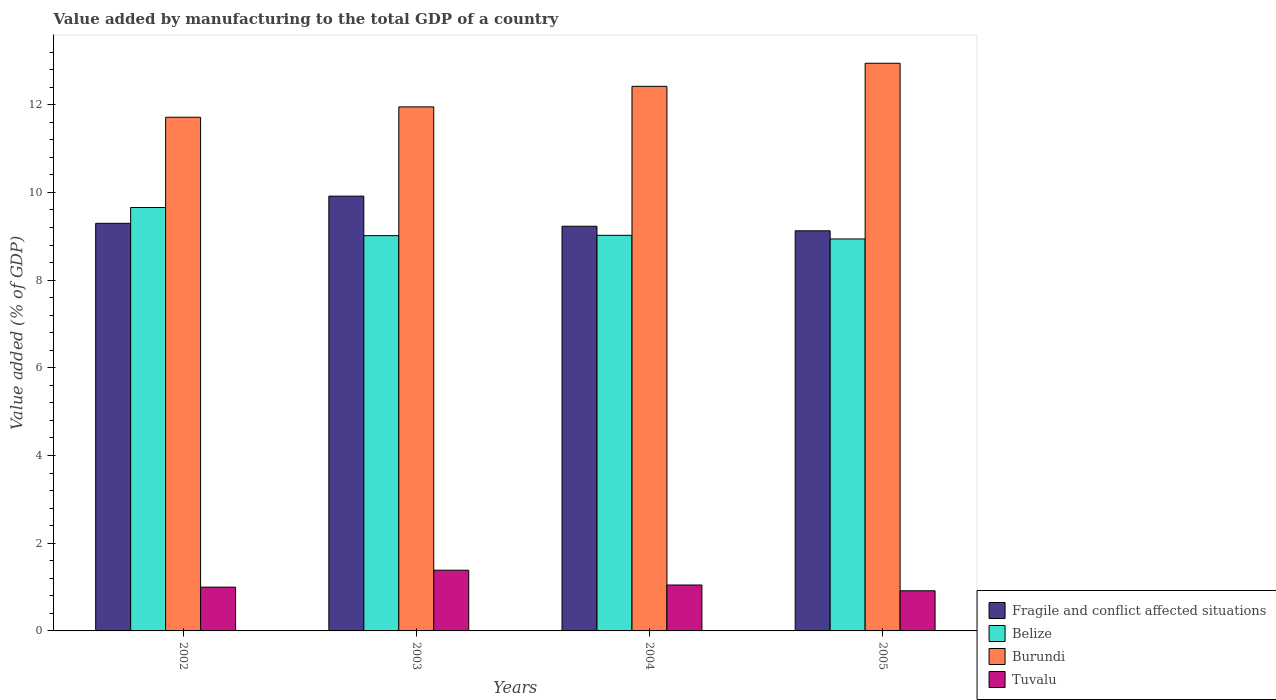How many different coloured bars are there?
Your answer should be very brief. 4. How many groups of bars are there?
Keep it short and to the point. 4. How many bars are there on the 3rd tick from the left?
Offer a terse response. 4. What is the value added by manufacturing to the total GDP in Burundi in 2003?
Ensure brevity in your answer.  11.95. Across all years, what is the maximum value added by manufacturing to the total GDP in Tuvalu?
Give a very brief answer. 1.38. Across all years, what is the minimum value added by manufacturing to the total GDP in Fragile and conflict affected situations?
Ensure brevity in your answer.  9.12. In which year was the value added by manufacturing to the total GDP in Tuvalu maximum?
Make the answer very short. 2003. What is the total value added by manufacturing to the total GDP in Burundi in the graph?
Your answer should be compact. 49.03. What is the difference between the value added by manufacturing to the total GDP in Belize in 2003 and that in 2004?
Keep it short and to the point. -0.01. What is the difference between the value added by manufacturing to the total GDP in Belize in 2005 and the value added by manufacturing to the total GDP in Fragile and conflict affected situations in 2002?
Provide a succinct answer. -0.36. What is the average value added by manufacturing to the total GDP in Fragile and conflict affected situations per year?
Offer a terse response. 9.39. In the year 2003, what is the difference between the value added by manufacturing to the total GDP in Burundi and value added by manufacturing to the total GDP in Belize?
Offer a terse response. 2.94. What is the ratio of the value added by manufacturing to the total GDP in Fragile and conflict affected situations in 2002 to that in 2005?
Your answer should be compact. 1.02. What is the difference between the highest and the second highest value added by manufacturing to the total GDP in Burundi?
Ensure brevity in your answer.  0.53. What is the difference between the highest and the lowest value added by manufacturing to the total GDP in Burundi?
Give a very brief answer. 1.23. In how many years, is the value added by manufacturing to the total GDP in Belize greater than the average value added by manufacturing to the total GDP in Belize taken over all years?
Give a very brief answer. 1. Is it the case that in every year, the sum of the value added by manufacturing to the total GDP in Tuvalu and value added by manufacturing to the total GDP in Burundi is greater than the sum of value added by manufacturing to the total GDP in Fragile and conflict affected situations and value added by manufacturing to the total GDP in Belize?
Provide a succinct answer. No. What does the 4th bar from the left in 2005 represents?
Your answer should be very brief. Tuvalu. What does the 2nd bar from the right in 2005 represents?
Make the answer very short. Burundi. How many bars are there?
Your answer should be compact. 16. Are all the bars in the graph horizontal?
Keep it short and to the point. No. How many years are there in the graph?
Your response must be concise. 4. Does the graph contain any zero values?
Provide a short and direct response. No. Does the graph contain grids?
Keep it short and to the point. No. How many legend labels are there?
Offer a terse response. 4. How are the legend labels stacked?
Offer a terse response. Vertical. What is the title of the graph?
Offer a very short reply. Value added by manufacturing to the total GDP of a country. Does "Malaysia" appear as one of the legend labels in the graph?
Your response must be concise. No. What is the label or title of the X-axis?
Provide a short and direct response. Years. What is the label or title of the Y-axis?
Your response must be concise. Value added (% of GDP). What is the Value added (% of GDP) in Fragile and conflict affected situations in 2002?
Keep it short and to the point. 9.3. What is the Value added (% of GDP) of Belize in 2002?
Keep it short and to the point. 9.66. What is the Value added (% of GDP) of Burundi in 2002?
Your response must be concise. 11.71. What is the Value added (% of GDP) in Tuvalu in 2002?
Offer a terse response. 1. What is the Value added (% of GDP) of Fragile and conflict affected situations in 2003?
Your answer should be very brief. 9.92. What is the Value added (% of GDP) in Belize in 2003?
Make the answer very short. 9.01. What is the Value added (% of GDP) of Burundi in 2003?
Your response must be concise. 11.95. What is the Value added (% of GDP) in Tuvalu in 2003?
Offer a very short reply. 1.38. What is the Value added (% of GDP) of Fragile and conflict affected situations in 2004?
Give a very brief answer. 9.23. What is the Value added (% of GDP) in Belize in 2004?
Make the answer very short. 9.02. What is the Value added (% of GDP) in Burundi in 2004?
Keep it short and to the point. 12.42. What is the Value added (% of GDP) in Tuvalu in 2004?
Provide a short and direct response. 1.05. What is the Value added (% of GDP) in Fragile and conflict affected situations in 2005?
Ensure brevity in your answer.  9.12. What is the Value added (% of GDP) in Belize in 2005?
Keep it short and to the point. 8.94. What is the Value added (% of GDP) of Burundi in 2005?
Provide a short and direct response. 12.95. What is the Value added (% of GDP) in Tuvalu in 2005?
Your answer should be compact. 0.92. Across all years, what is the maximum Value added (% of GDP) of Fragile and conflict affected situations?
Offer a very short reply. 9.92. Across all years, what is the maximum Value added (% of GDP) of Belize?
Keep it short and to the point. 9.66. Across all years, what is the maximum Value added (% of GDP) of Burundi?
Provide a succinct answer. 12.95. Across all years, what is the maximum Value added (% of GDP) of Tuvalu?
Give a very brief answer. 1.38. Across all years, what is the minimum Value added (% of GDP) of Fragile and conflict affected situations?
Your answer should be compact. 9.12. Across all years, what is the minimum Value added (% of GDP) in Belize?
Offer a very short reply. 8.94. Across all years, what is the minimum Value added (% of GDP) of Burundi?
Offer a terse response. 11.71. Across all years, what is the minimum Value added (% of GDP) in Tuvalu?
Make the answer very short. 0.92. What is the total Value added (% of GDP) in Fragile and conflict affected situations in the graph?
Keep it short and to the point. 37.56. What is the total Value added (% of GDP) of Belize in the graph?
Keep it short and to the point. 36.63. What is the total Value added (% of GDP) in Burundi in the graph?
Ensure brevity in your answer.  49.03. What is the total Value added (% of GDP) of Tuvalu in the graph?
Ensure brevity in your answer.  4.35. What is the difference between the Value added (% of GDP) in Fragile and conflict affected situations in 2002 and that in 2003?
Your answer should be very brief. -0.62. What is the difference between the Value added (% of GDP) of Belize in 2002 and that in 2003?
Your answer should be compact. 0.64. What is the difference between the Value added (% of GDP) of Burundi in 2002 and that in 2003?
Offer a terse response. -0.24. What is the difference between the Value added (% of GDP) of Tuvalu in 2002 and that in 2003?
Ensure brevity in your answer.  -0.39. What is the difference between the Value added (% of GDP) of Fragile and conflict affected situations in 2002 and that in 2004?
Offer a terse response. 0.07. What is the difference between the Value added (% of GDP) in Belize in 2002 and that in 2004?
Provide a short and direct response. 0.63. What is the difference between the Value added (% of GDP) in Burundi in 2002 and that in 2004?
Offer a terse response. -0.7. What is the difference between the Value added (% of GDP) in Tuvalu in 2002 and that in 2004?
Your answer should be compact. -0.05. What is the difference between the Value added (% of GDP) of Fragile and conflict affected situations in 2002 and that in 2005?
Keep it short and to the point. 0.17. What is the difference between the Value added (% of GDP) of Belize in 2002 and that in 2005?
Provide a succinct answer. 0.72. What is the difference between the Value added (% of GDP) of Burundi in 2002 and that in 2005?
Provide a succinct answer. -1.23. What is the difference between the Value added (% of GDP) in Tuvalu in 2002 and that in 2005?
Give a very brief answer. 0.08. What is the difference between the Value added (% of GDP) of Fragile and conflict affected situations in 2003 and that in 2004?
Your answer should be compact. 0.69. What is the difference between the Value added (% of GDP) in Belize in 2003 and that in 2004?
Keep it short and to the point. -0.01. What is the difference between the Value added (% of GDP) in Burundi in 2003 and that in 2004?
Your answer should be compact. -0.47. What is the difference between the Value added (% of GDP) of Tuvalu in 2003 and that in 2004?
Your response must be concise. 0.34. What is the difference between the Value added (% of GDP) of Fragile and conflict affected situations in 2003 and that in 2005?
Your response must be concise. 0.79. What is the difference between the Value added (% of GDP) of Belize in 2003 and that in 2005?
Offer a very short reply. 0.08. What is the difference between the Value added (% of GDP) in Burundi in 2003 and that in 2005?
Make the answer very short. -0.99. What is the difference between the Value added (% of GDP) of Tuvalu in 2003 and that in 2005?
Your response must be concise. 0.47. What is the difference between the Value added (% of GDP) of Fragile and conflict affected situations in 2004 and that in 2005?
Make the answer very short. 0.1. What is the difference between the Value added (% of GDP) in Belize in 2004 and that in 2005?
Offer a very short reply. 0.08. What is the difference between the Value added (% of GDP) of Burundi in 2004 and that in 2005?
Your answer should be compact. -0.53. What is the difference between the Value added (% of GDP) in Tuvalu in 2004 and that in 2005?
Provide a short and direct response. 0.13. What is the difference between the Value added (% of GDP) in Fragile and conflict affected situations in 2002 and the Value added (% of GDP) in Belize in 2003?
Keep it short and to the point. 0.28. What is the difference between the Value added (% of GDP) of Fragile and conflict affected situations in 2002 and the Value added (% of GDP) of Burundi in 2003?
Offer a very short reply. -2.65. What is the difference between the Value added (% of GDP) in Fragile and conflict affected situations in 2002 and the Value added (% of GDP) in Tuvalu in 2003?
Keep it short and to the point. 7.91. What is the difference between the Value added (% of GDP) in Belize in 2002 and the Value added (% of GDP) in Burundi in 2003?
Your answer should be compact. -2.29. What is the difference between the Value added (% of GDP) of Belize in 2002 and the Value added (% of GDP) of Tuvalu in 2003?
Provide a short and direct response. 8.27. What is the difference between the Value added (% of GDP) of Burundi in 2002 and the Value added (% of GDP) of Tuvalu in 2003?
Your response must be concise. 10.33. What is the difference between the Value added (% of GDP) of Fragile and conflict affected situations in 2002 and the Value added (% of GDP) of Belize in 2004?
Offer a very short reply. 0.27. What is the difference between the Value added (% of GDP) of Fragile and conflict affected situations in 2002 and the Value added (% of GDP) of Burundi in 2004?
Provide a succinct answer. -3.12. What is the difference between the Value added (% of GDP) in Fragile and conflict affected situations in 2002 and the Value added (% of GDP) in Tuvalu in 2004?
Ensure brevity in your answer.  8.25. What is the difference between the Value added (% of GDP) in Belize in 2002 and the Value added (% of GDP) in Burundi in 2004?
Keep it short and to the point. -2.76. What is the difference between the Value added (% of GDP) in Belize in 2002 and the Value added (% of GDP) in Tuvalu in 2004?
Your response must be concise. 8.61. What is the difference between the Value added (% of GDP) of Burundi in 2002 and the Value added (% of GDP) of Tuvalu in 2004?
Your answer should be compact. 10.67. What is the difference between the Value added (% of GDP) of Fragile and conflict affected situations in 2002 and the Value added (% of GDP) of Belize in 2005?
Your answer should be compact. 0.36. What is the difference between the Value added (% of GDP) in Fragile and conflict affected situations in 2002 and the Value added (% of GDP) in Burundi in 2005?
Provide a succinct answer. -3.65. What is the difference between the Value added (% of GDP) in Fragile and conflict affected situations in 2002 and the Value added (% of GDP) in Tuvalu in 2005?
Give a very brief answer. 8.38. What is the difference between the Value added (% of GDP) in Belize in 2002 and the Value added (% of GDP) in Burundi in 2005?
Ensure brevity in your answer.  -3.29. What is the difference between the Value added (% of GDP) in Belize in 2002 and the Value added (% of GDP) in Tuvalu in 2005?
Keep it short and to the point. 8.74. What is the difference between the Value added (% of GDP) in Burundi in 2002 and the Value added (% of GDP) in Tuvalu in 2005?
Offer a terse response. 10.8. What is the difference between the Value added (% of GDP) of Fragile and conflict affected situations in 2003 and the Value added (% of GDP) of Belize in 2004?
Your response must be concise. 0.89. What is the difference between the Value added (% of GDP) of Fragile and conflict affected situations in 2003 and the Value added (% of GDP) of Burundi in 2004?
Give a very brief answer. -2.5. What is the difference between the Value added (% of GDP) in Fragile and conflict affected situations in 2003 and the Value added (% of GDP) in Tuvalu in 2004?
Ensure brevity in your answer.  8.87. What is the difference between the Value added (% of GDP) of Belize in 2003 and the Value added (% of GDP) of Burundi in 2004?
Your answer should be very brief. -3.4. What is the difference between the Value added (% of GDP) in Belize in 2003 and the Value added (% of GDP) in Tuvalu in 2004?
Provide a short and direct response. 7.97. What is the difference between the Value added (% of GDP) in Burundi in 2003 and the Value added (% of GDP) in Tuvalu in 2004?
Give a very brief answer. 10.9. What is the difference between the Value added (% of GDP) in Fragile and conflict affected situations in 2003 and the Value added (% of GDP) in Belize in 2005?
Provide a succinct answer. 0.98. What is the difference between the Value added (% of GDP) in Fragile and conflict affected situations in 2003 and the Value added (% of GDP) in Burundi in 2005?
Offer a terse response. -3.03. What is the difference between the Value added (% of GDP) in Fragile and conflict affected situations in 2003 and the Value added (% of GDP) in Tuvalu in 2005?
Offer a very short reply. 9. What is the difference between the Value added (% of GDP) of Belize in 2003 and the Value added (% of GDP) of Burundi in 2005?
Keep it short and to the point. -3.93. What is the difference between the Value added (% of GDP) of Belize in 2003 and the Value added (% of GDP) of Tuvalu in 2005?
Ensure brevity in your answer.  8.1. What is the difference between the Value added (% of GDP) of Burundi in 2003 and the Value added (% of GDP) of Tuvalu in 2005?
Your answer should be compact. 11.03. What is the difference between the Value added (% of GDP) of Fragile and conflict affected situations in 2004 and the Value added (% of GDP) of Belize in 2005?
Provide a short and direct response. 0.29. What is the difference between the Value added (% of GDP) of Fragile and conflict affected situations in 2004 and the Value added (% of GDP) of Burundi in 2005?
Your answer should be very brief. -3.72. What is the difference between the Value added (% of GDP) in Fragile and conflict affected situations in 2004 and the Value added (% of GDP) in Tuvalu in 2005?
Offer a very short reply. 8.31. What is the difference between the Value added (% of GDP) of Belize in 2004 and the Value added (% of GDP) of Burundi in 2005?
Provide a short and direct response. -3.92. What is the difference between the Value added (% of GDP) in Belize in 2004 and the Value added (% of GDP) in Tuvalu in 2005?
Offer a terse response. 8.11. What is the difference between the Value added (% of GDP) in Burundi in 2004 and the Value added (% of GDP) in Tuvalu in 2005?
Provide a succinct answer. 11.5. What is the average Value added (% of GDP) of Fragile and conflict affected situations per year?
Offer a very short reply. 9.39. What is the average Value added (% of GDP) in Belize per year?
Make the answer very short. 9.16. What is the average Value added (% of GDP) of Burundi per year?
Offer a very short reply. 12.26. What is the average Value added (% of GDP) of Tuvalu per year?
Ensure brevity in your answer.  1.09. In the year 2002, what is the difference between the Value added (% of GDP) in Fragile and conflict affected situations and Value added (% of GDP) in Belize?
Give a very brief answer. -0.36. In the year 2002, what is the difference between the Value added (% of GDP) in Fragile and conflict affected situations and Value added (% of GDP) in Burundi?
Provide a succinct answer. -2.42. In the year 2002, what is the difference between the Value added (% of GDP) of Fragile and conflict affected situations and Value added (% of GDP) of Tuvalu?
Your answer should be very brief. 8.3. In the year 2002, what is the difference between the Value added (% of GDP) in Belize and Value added (% of GDP) in Burundi?
Ensure brevity in your answer.  -2.06. In the year 2002, what is the difference between the Value added (% of GDP) of Belize and Value added (% of GDP) of Tuvalu?
Your answer should be compact. 8.66. In the year 2002, what is the difference between the Value added (% of GDP) in Burundi and Value added (% of GDP) in Tuvalu?
Provide a succinct answer. 10.72. In the year 2003, what is the difference between the Value added (% of GDP) of Fragile and conflict affected situations and Value added (% of GDP) of Belize?
Give a very brief answer. 0.9. In the year 2003, what is the difference between the Value added (% of GDP) in Fragile and conflict affected situations and Value added (% of GDP) in Burundi?
Ensure brevity in your answer.  -2.04. In the year 2003, what is the difference between the Value added (% of GDP) in Fragile and conflict affected situations and Value added (% of GDP) in Tuvalu?
Give a very brief answer. 8.53. In the year 2003, what is the difference between the Value added (% of GDP) in Belize and Value added (% of GDP) in Burundi?
Make the answer very short. -2.94. In the year 2003, what is the difference between the Value added (% of GDP) in Belize and Value added (% of GDP) in Tuvalu?
Give a very brief answer. 7.63. In the year 2003, what is the difference between the Value added (% of GDP) of Burundi and Value added (% of GDP) of Tuvalu?
Your response must be concise. 10.57. In the year 2004, what is the difference between the Value added (% of GDP) of Fragile and conflict affected situations and Value added (% of GDP) of Belize?
Your answer should be compact. 0.21. In the year 2004, what is the difference between the Value added (% of GDP) in Fragile and conflict affected situations and Value added (% of GDP) in Burundi?
Make the answer very short. -3.19. In the year 2004, what is the difference between the Value added (% of GDP) in Fragile and conflict affected situations and Value added (% of GDP) in Tuvalu?
Your answer should be compact. 8.18. In the year 2004, what is the difference between the Value added (% of GDP) in Belize and Value added (% of GDP) in Burundi?
Your answer should be compact. -3.4. In the year 2004, what is the difference between the Value added (% of GDP) in Belize and Value added (% of GDP) in Tuvalu?
Offer a terse response. 7.97. In the year 2004, what is the difference between the Value added (% of GDP) of Burundi and Value added (% of GDP) of Tuvalu?
Give a very brief answer. 11.37. In the year 2005, what is the difference between the Value added (% of GDP) of Fragile and conflict affected situations and Value added (% of GDP) of Belize?
Ensure brevity in your answer.  0.19. In the year 2005, what is the difference between the Value added (% of GDP) in Fragile and conflict affected situations and Value added (% of GDP) in Burundi?
Offer a terse response. -3.82. In the year 2005, what is the difference between the Value added (% of GDP) in Fragile and conflict affected situations and Value added (% of GDP) in Tuvalu?
Make the answer very short. 8.21. In the year 2005, what is the difference between the Value added (% of GDP) of Belize and Value added (% of GDP) of Burundi?
Provide a succinct answer. -4.01. In the year 2005, what is the difference between the Value added (% of GDP) of Belize and Value added (% of GDP) of Tuvalu?
Offer a very short reply. 8.02. In the year 2005, what is the difference between the Value added (% of GDP) of Burundi and Value added (% of GDP) of Tuvalu?
Provide a succinct answer. 12.03. What is the ratio of the Value added (% of GDP) in Fragile and conflict affected situations in 2002 to that in 2003?
Give a very brief answer. 0.94. What is the ratio of the Value added (% of GDP) of Belize in 2002 to that in 2003?
Offer a very short reply. 1.07. What is the ratio of the Value added (% of GDP) in Burundi in 2002 to that in 2003?
Your response must be concise. 0.98. What is the ratio of the Value added (% of GDP) of Tuvalu in 2002 to that in 2003?
Provide a short and direct response. 0.72. What is the ratio of the Value added (% of GDP) of Fragile and conflict affected situations in 2002 to that in 2004?
Ensure brevity in your answer.  1.01. What is the ratio of the Value added (% of GDP) in Belize in 2002 to that in 2004?
Make the answer very short. 1.07. What is the ratio of the Value added (% of GDP) of Burundi in 2002 to that in 2004?
Your answer should be compact. 0.94. What is the ratio of the Value added (% of GDP) in Tuvalu in 2002 to that in 2004?
Provide a succinct answer. 0.95. What is the ratio of the Value added (% of GDP) of Fragile and conflict affected situations in 2002 to that in 2005?
Keep it short and to the point. 1.02. What is the ratio of the Value added (% of GDP) in Belize in 2002 to that in 2005?
Your answer should be very brief. 1.08. What is the ratio of the Value added (% of GDP) of Burundi in 2002 to that in 2005?
Offer a terse response. 0.9. What is the ratio of the Value added (% of GDP) of Tuvalu in 2002 to that in 2005?
Ensure brevity in your answer.  1.09. What is the ratio of the Value added (% of GDP) in Fragile and conflict affected situations in 2003 to that in 2004?
Make the answer very short. 1.07. What is the ratio of the Value added (% of GDP) in Belize in 2003 to that in 2004?
Ensure brevity in your answer.  1. What is the ratio of the Value added (% of GDP) in Burundi in 2003 to that in 2004?
Provide a short and direct response. 0.96. What is the ratio of the Value added (% of GDP) of Tuvalu in 2003 to that in 2004?
Your answer should be very brief. 1.32. What is the ratio of the Value added (% of GDP) of Fragile and conflict affected situations in 2003 to that in 2005?
Give a very brief answer. 1.09. What is the ratio of the Value added (% of GDP) of Belize in 2003 to that in 2005?
Provide a succinct answer. 1.01. What is the ratio of the Value added (% of GDP) of Burundi in 2003 to that in 2005?
Give a very brief answer. 0.92. What is the ratio of the Value added (% of GDP) in Tuvalu in 2003 to that in 2005?
Give a very brief answer. 1.51. What is the ratio of the Value added (% of GDP) in Fragile and conflict affected situations in 2004 to that in 2005?
Provide a succinct answer. 1.01. What is the ratio of the Value added (% of GDP) in Belize in 2004 to that in 2005?
Your response must be concise. 1.01. What is the ratio of the Value added (% of GDP) of Burundi in 2004 to that in 2005?
Your answer should be very brief. 0.96. What is the ratio of the Value added (% of GDP) of Tuvalu in 2004 to that in 2005?
Give a very brief answer. 1.14. What is the difference between the highest and the second highest Value added (% of GDP) in Fragile and conflict affected situations?
Give a very brief answer. 0.62. What is the difference between the highest and the second highest Value added (% of GDP) of Belize?
Ensure brevity in your answer.  0.63. What is the difference between the highest and the second highest Value added (% of GDP) in Burundi?
Offer a very short reply. 0.53. What is the difference between the highest and the second highest Value added (% of GDP) in Tuvalu?
Your answer should be compact. 0.34. What is the difference between the highest and the lowest Value added (% of GDP) in Fragile and conflict affected situations?
Provide a short and direct response. 0.79. What is the difference between the highest and the lowest Value added (% of GDP) of Belize?
Make the answer very short. 0.72. What is the difference between the highest and the lowest Value added (% of GDP) in Burundi?
Give a very brief answer. 1.23. What is the difference between the highest and the lowest Value added (% of GDP) in Tuvalu?
Your answer should be very brief. 0.47. 